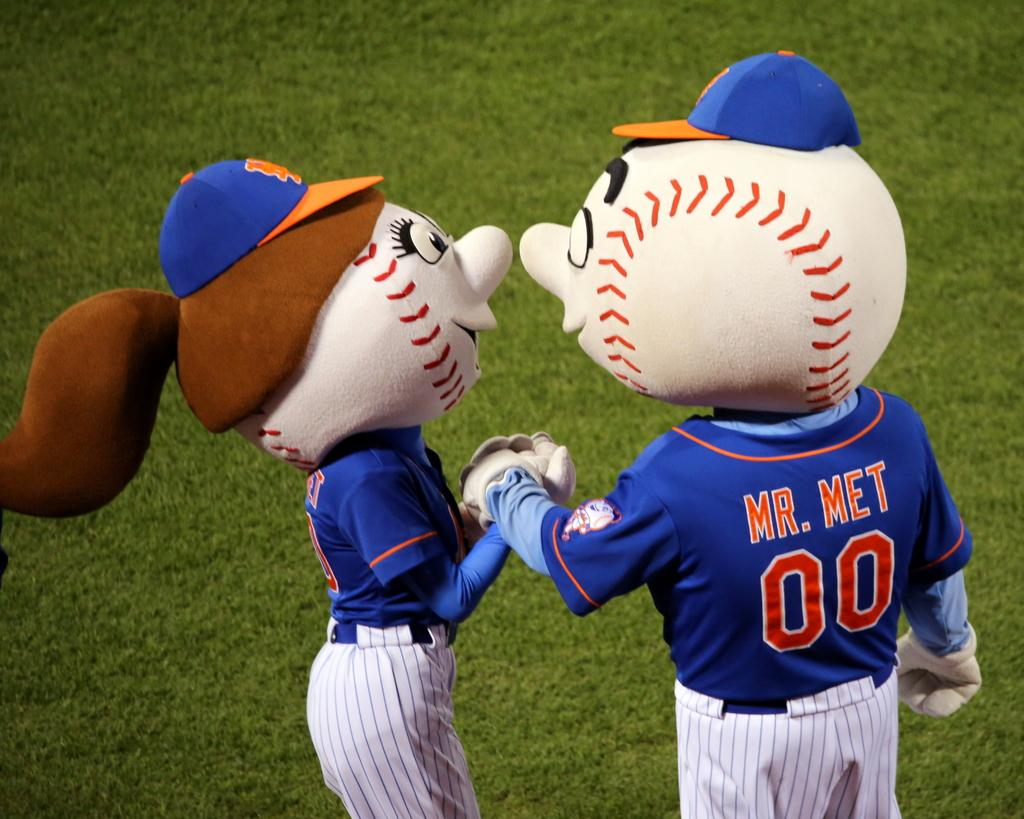<image>
Give a short and clear explanation of the subsequent image. MR. MET is one of the costumes being worn on the field. 